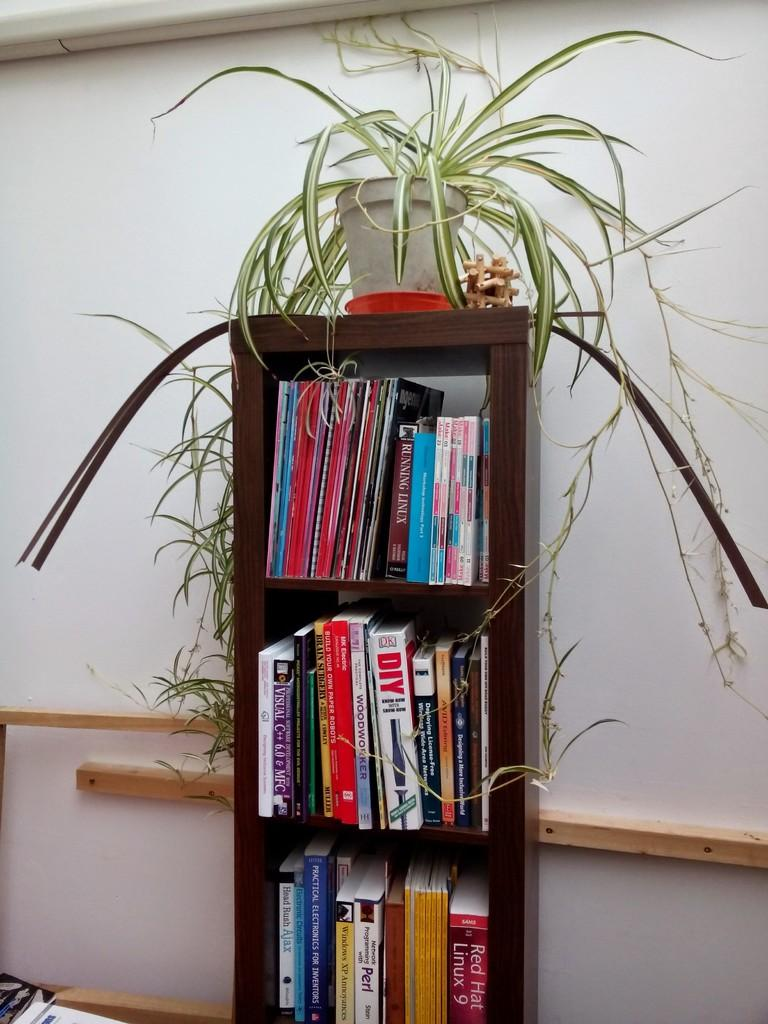What is the main object in the center of the image? There is a bookshelf in the center of the image. What is stored on the bookshelf? The bookshelf contains books. Is there anything else on the bookshelf besides books? Yes, there is a plant pot on top of the bookshelf. Can you see any dolls attempting to farm on the bookshelf? No, there are no dolls or farming activities present on the bookshelf in the image. 